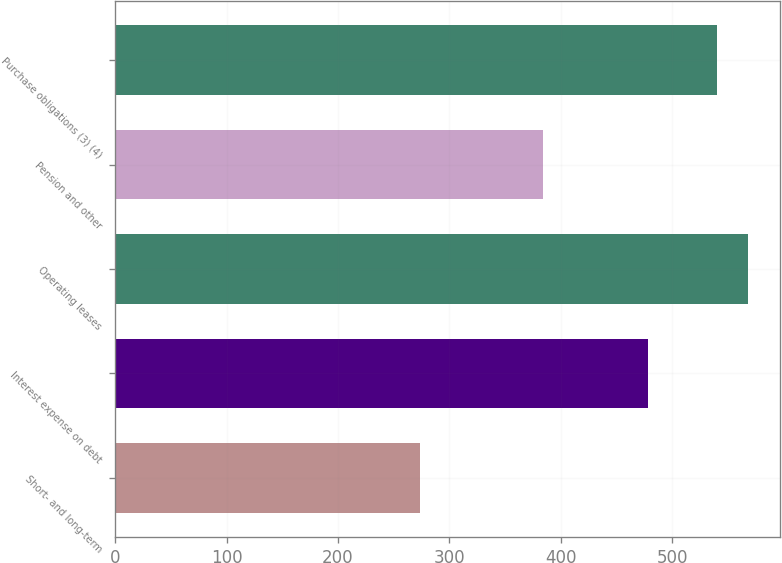<chart> <loc_0><loc_0><loc_500><loc_500><bar_chart><fcel>Short- and long-term<fcel>Interest expense on debt<fcel>Operating leases<fcel>Pension and other<fcel>Purchase obligations (3) (4)<nl><fcel>274<fcel>478<fcel>568.4<fcel>384<fcel>540<nl></chart> 